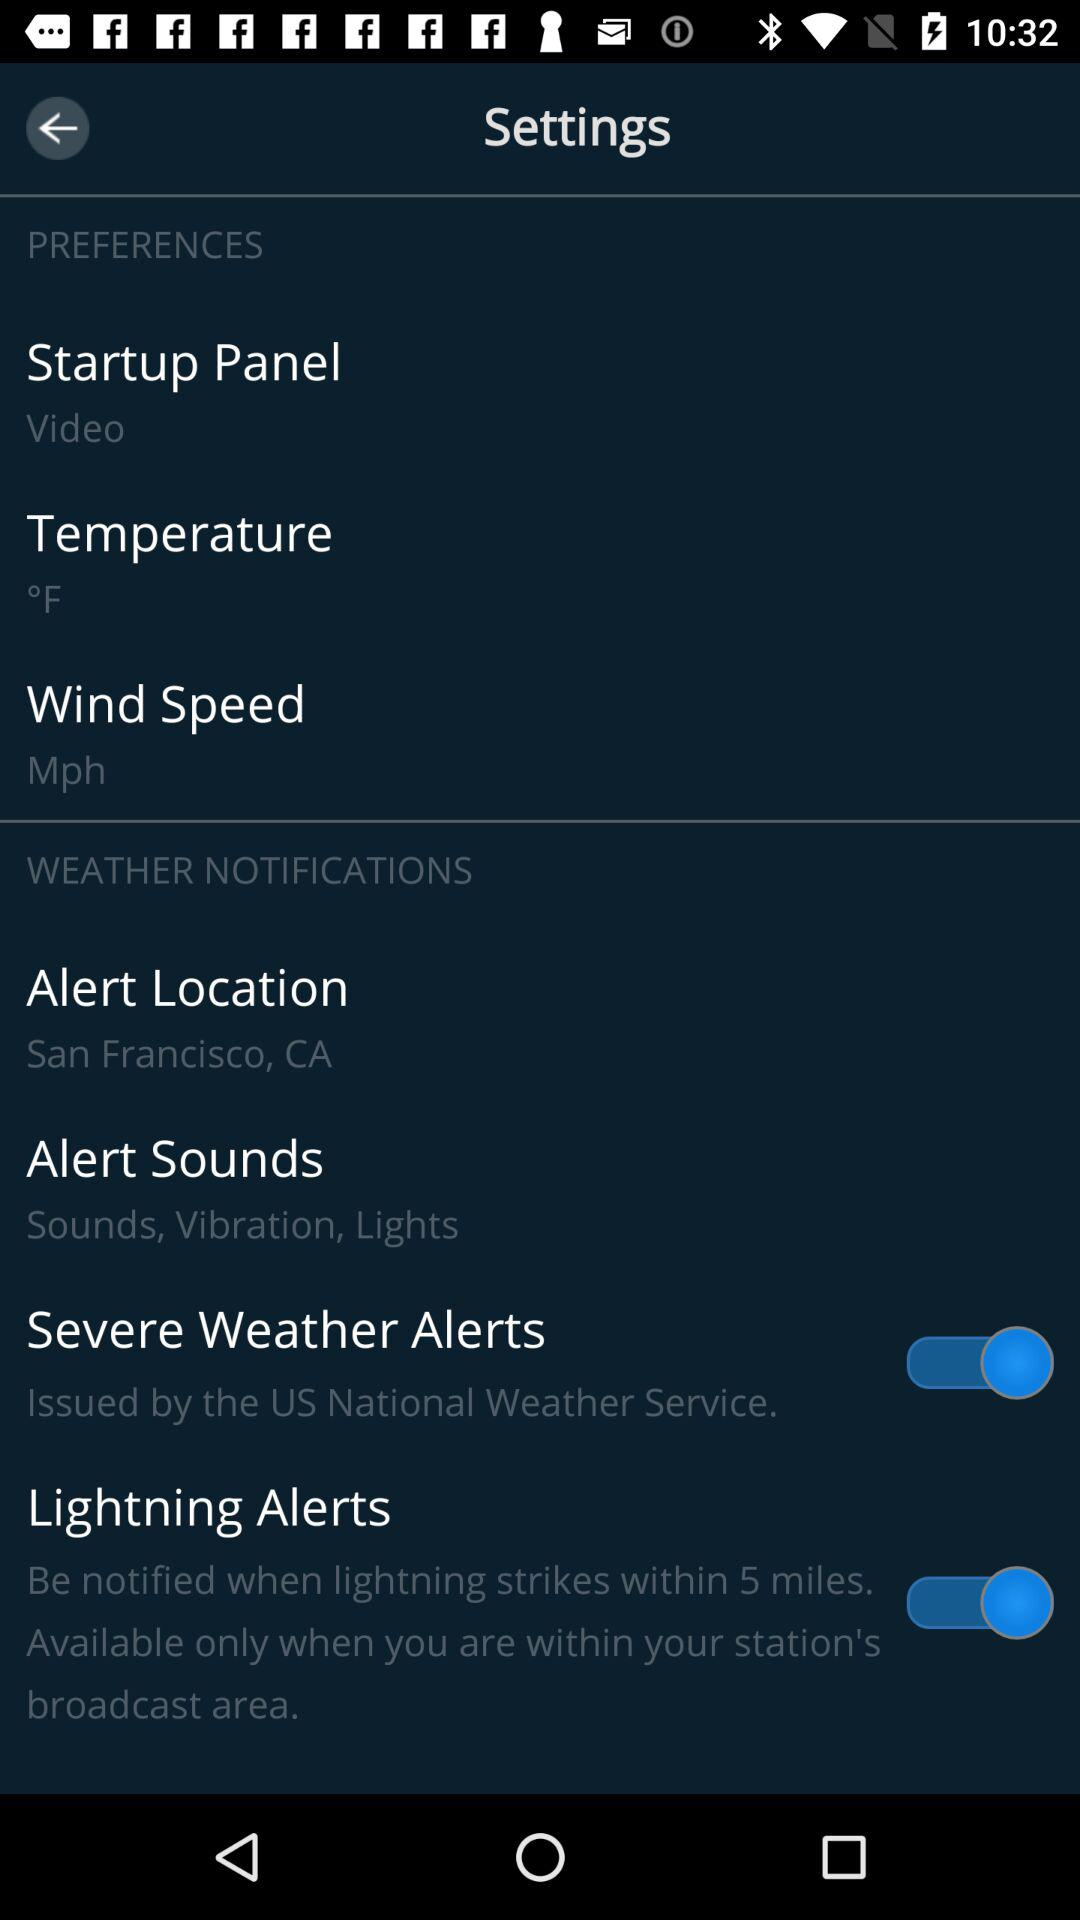What is the "Alert Location"? The "Alert Location" is San Francisco, CA. 